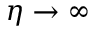Convert formula to latex. <formula><loc_0><loc_0><loc_500><loc_500>\eta \to \infty</formula> 